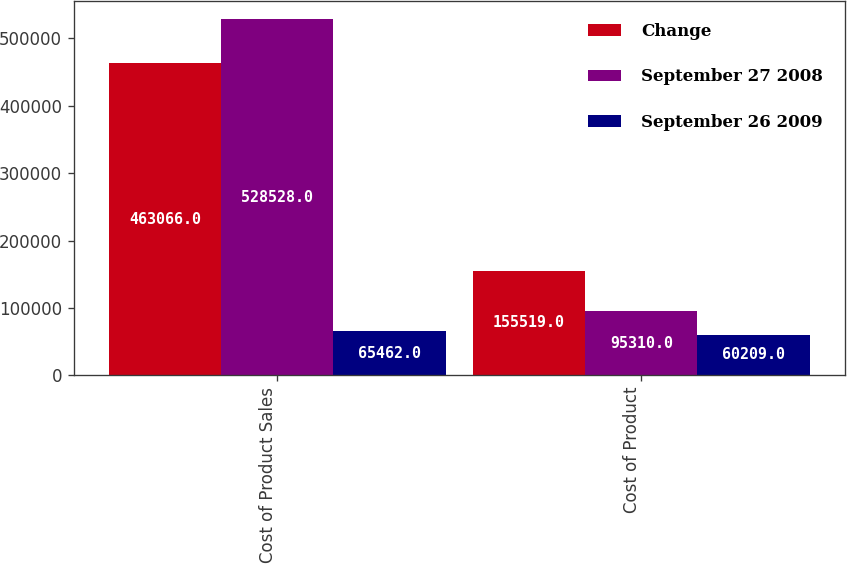<chart> <loc_0><loc_0><loc_500><loc_500><stacked_bar_chart><ecel><fcel>Cost of Product Sales<fcel>Cost of Product<nl><fcel>Change<fcel>463066<fcel>155519<nl><fcel>September 27 2008<fcel>528528<fcel>95310<nl><fcel>September 26 2009<fcel>65462<fcel>60209<nl></chart> 